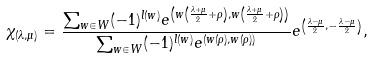Convert formula to latex. <formula><loc_0><loc_0><loc_500><loc_500>\chi _ { ( \lambda , \mu ) } = \frac { \sum _ { w \in W } ( - 1 ) ^ { l ( w ) } e ^ { \left ( w \left ( \frac { \lambda + \mu } { 2 } + \rho \right ) , w \left ( \frac { \lambda + \mu } { 2 } + \rho \right ) \right ) } } { \sum _ { w \in W } ( - 1 ) ^ { l ( w ) } e ^ { ( w ( \rho ) , w ( \rho ) ) } } e ^ { \left ( \frac { \lambda - \mu } { 2 } , - \frac { \lambda - \mu } { 2 } \right ) } ,</formula> 